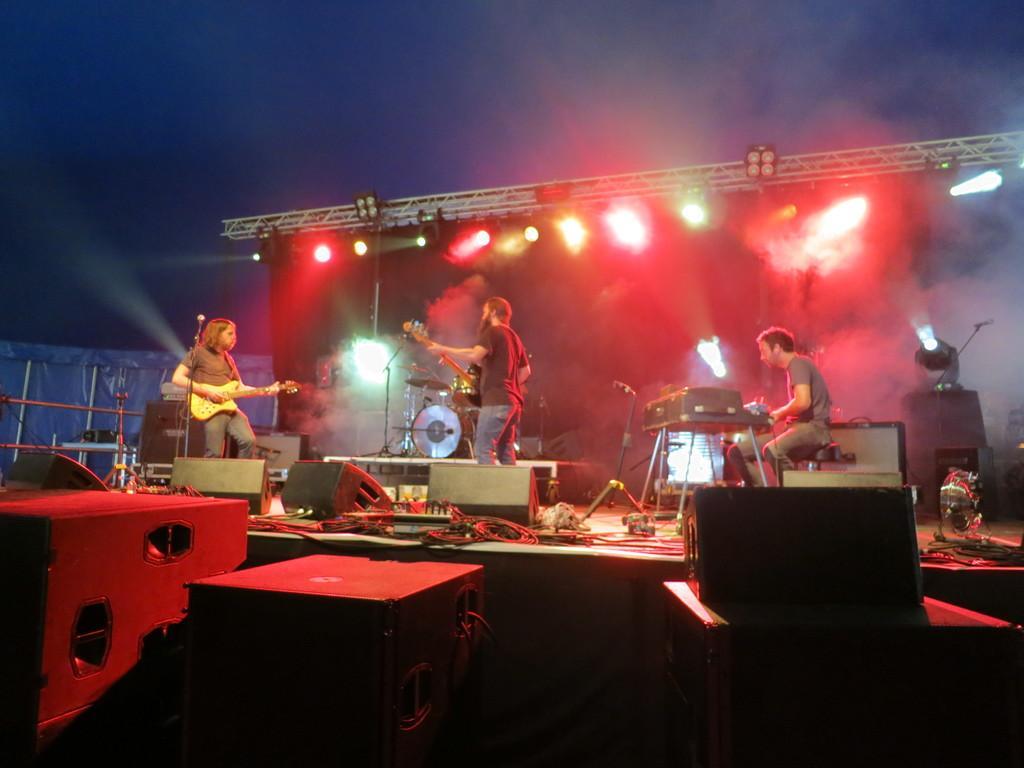Please provide a concise description of this image. On the left side, there are two persons holding guitars and standing on a stage, on which there are speakers and lights arranged. On the right side, there is a person sitting in front of an object which is on a table. Beside this stage, there is are boxes. In the background, there is the sky. 